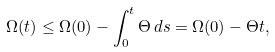Convert formula to latex. <formula><loc_0><loc_0><loc_500><loc_500>\Omega ( t ) \leq \Omega ( 0 ) - \int _ { 0 } ^ { t } \Theta \, d s = \Omega ( 0 ) - \Theta t ,</formula> 